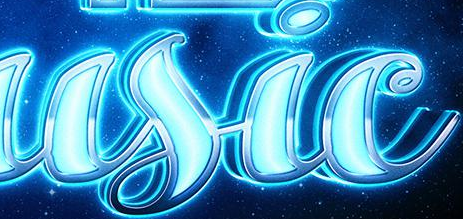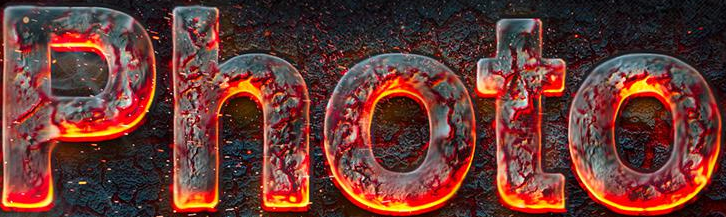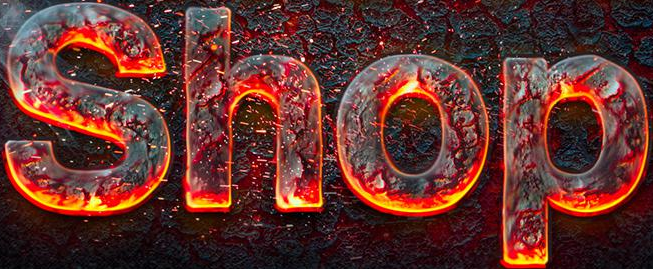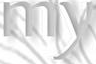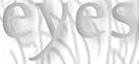Identify the words shown in these images in order, separated by a semicolon. usic; Photo; Shop; my; eyes 